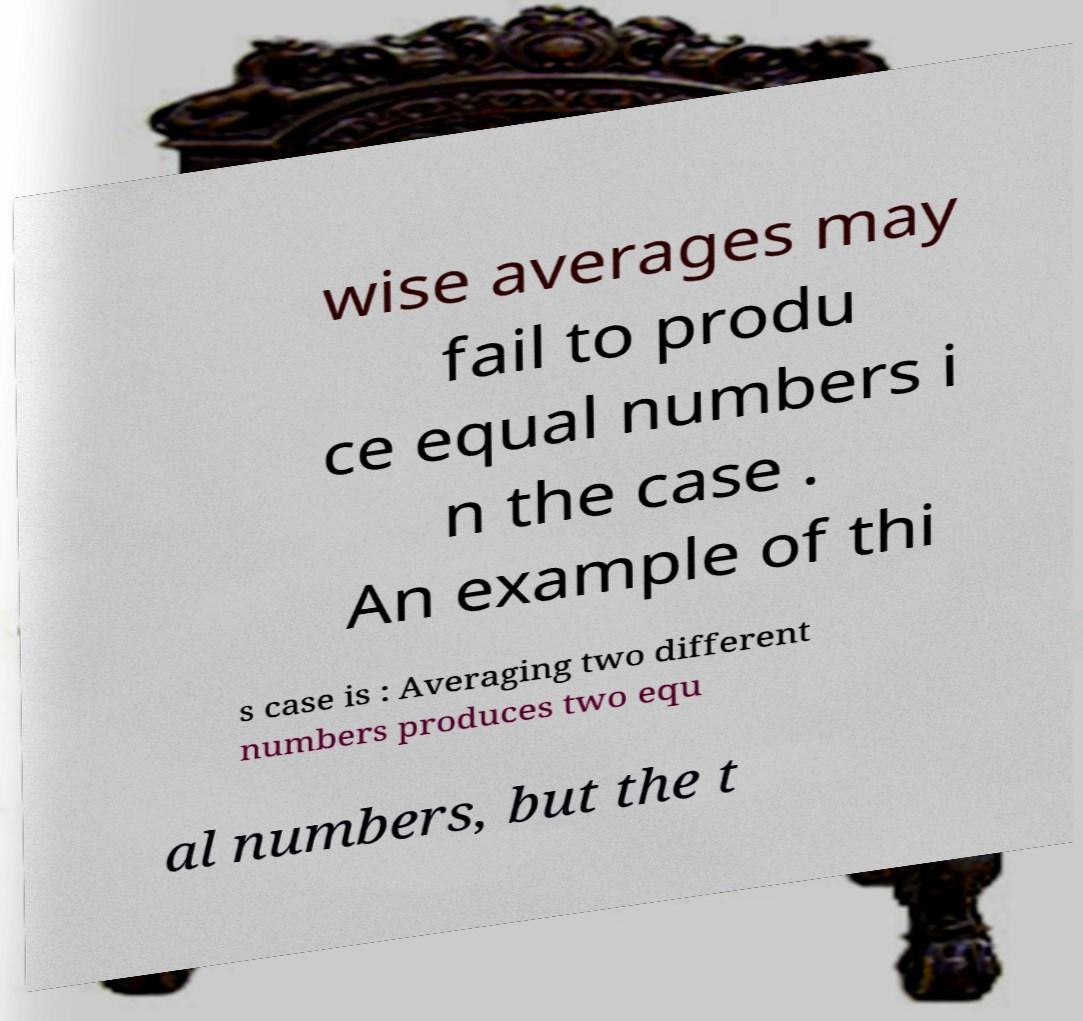Can you accurately transcribe the text from the provided image for me? wise averages may fail to produ ce equal numbers i n the case . An example of thi s case is : Averaging two different numbers produces two equ al numbers, but the t 